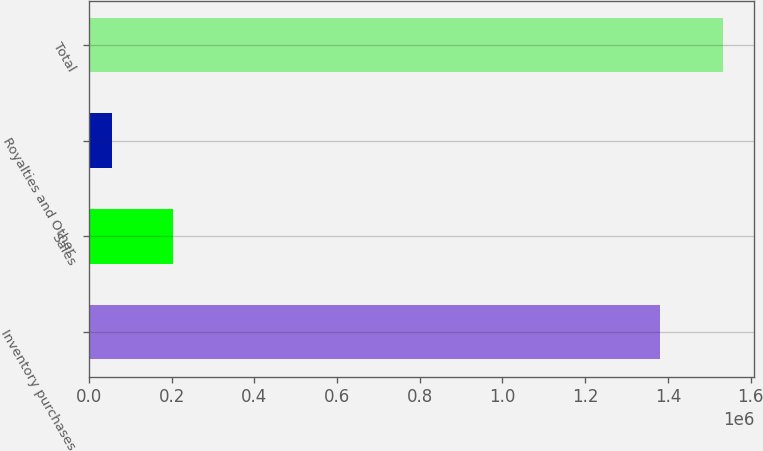Convert chart. <chart><loc_0><loc_0><loc_500><loc_500><bar_chart><fcel>Inventory purchases<fcel>Sales<fcel>Royalties and Other<fcel>Total<nl><fcel>1.38049e+06<fcel>202144<fcel>54360<fcel>1.5322e+06<nl></chart> 